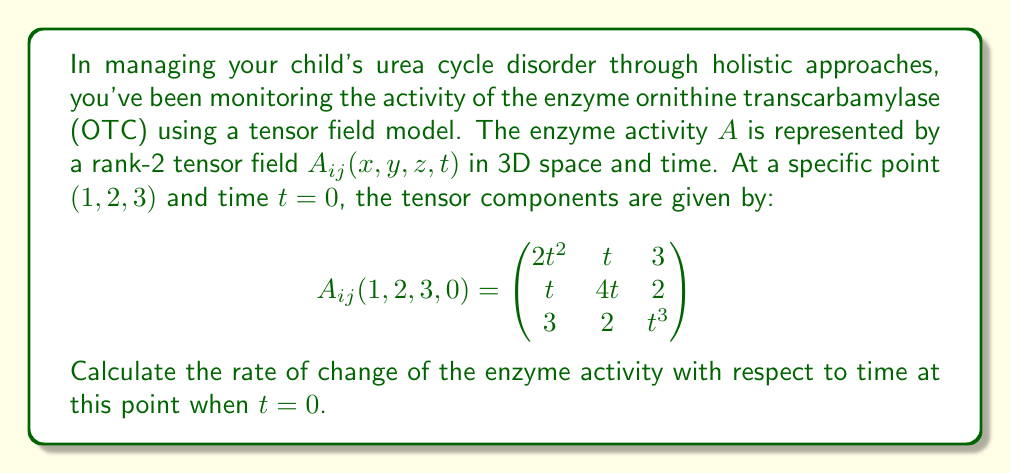Give your solution to this math problem. To solve this problem, we need to follow these steps:

1) The rate of change of enzyme activity with respect to time is given by the time derivative of the tensor field. In tensor notation, this is represented as $\frac{\partial A_{ij}}{\partial t}$.

2) To calculate this, we need to differentiate each component of the tensor with respect to t:

   $$\frac{\partial A_{ij}}{\partial t} = \begin{pmatrix}
   \frac{\partial}{\partial t}(2t^2) & \frac{\partial}{\partial t}(t) & \frac{\partial}{\partial t}(3) \\
   \frac{\partial}{\partial t}(t) & \frac{\partial}{\partial t}(4t) & \frac{\partial}{\partial t}(2) \\
   \frac{\partial}{\partial t}(3) & \frac{\partial}{\partial t}(2) & \frac{\partial}{\partial t}(t^3)
   \end{pmatrix}$$

3) Performing the differentiations:

   $$\frac{\partial A_{ij}}{\partial t} = \begin{pmatrix}
   4t & 1 & 0 \\
   1 & 4 & 0 \\
   0 & 0 & 3t^2
   \end{pmatrix}$$

4) Now, we need to evaluate this at $t=0$:

   $$\left.\frac{\partial A_{ij}}{\partial t}\right|_{t=0} = \begin{pmatrix}
   0 & 1 & 0 \\
   1 & 4 & 0 \\
   0 & 0 & 0
   \end{pmatrix}$$

5) The rate of change of enzyme activity is represented by this resulting tensor. In tensor analysis, a common way to represent the magnitude of a tensor is through its Frobenius norm, which is the square root of the sum of the squares of its elements.

6) The Frobenius norm of this tensor is:

   $$\sqrt{0^2 + 1^2 + 0^2 + 1^2 + 4^2 + 0^2 + 0^2 + 0^2 + 0^2} = \sqrt{18} = 3\sqrt{2}$$

Therefore, the rate of change of enzyme activity at the given point and time is $3\sqrt{2}$ units per time.
Answer: $3\sqrt{2}$ units/time 